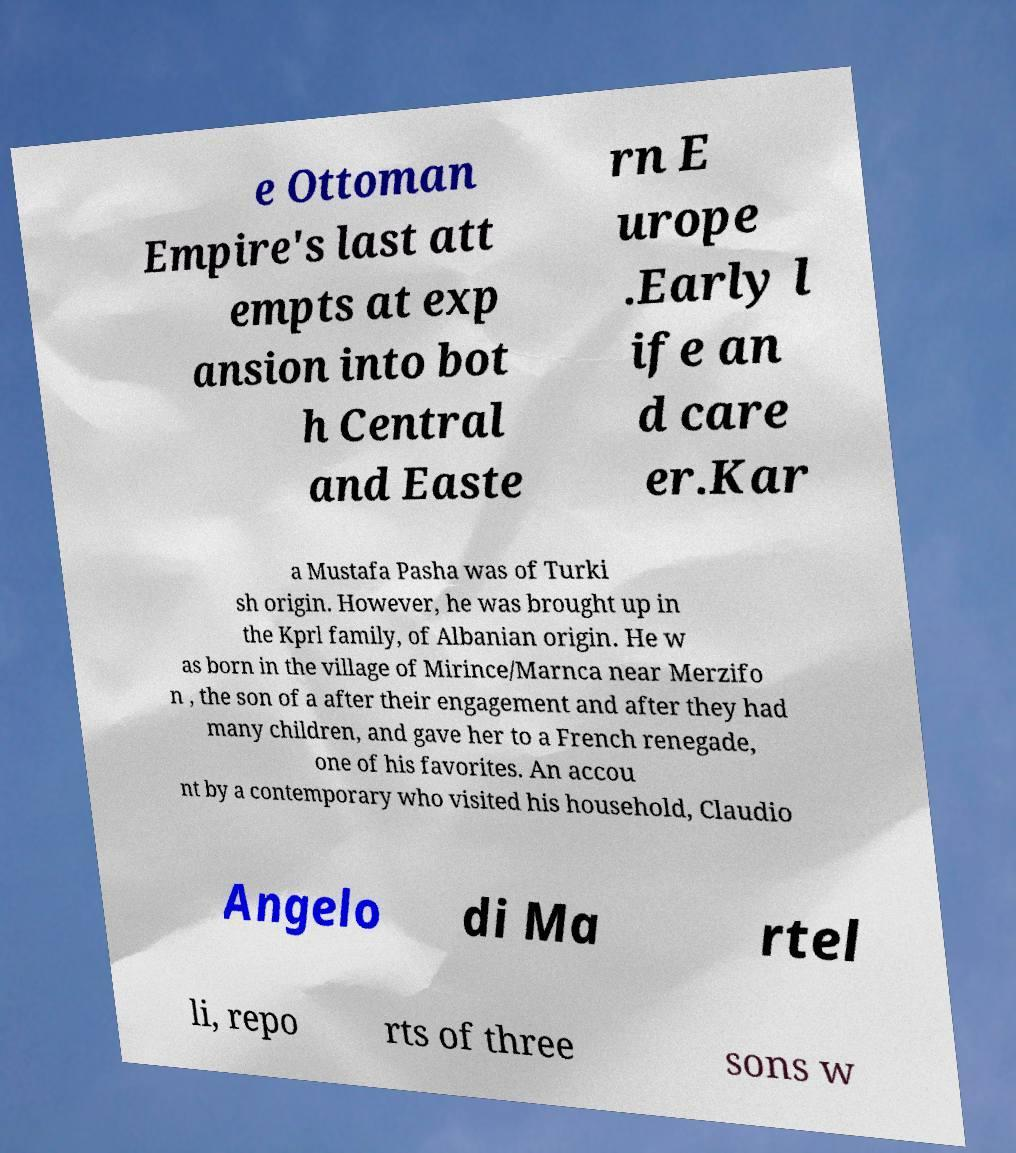What messages or text are displayed in this image? I need them in a readable, typed format. e Ottoman Empire's last att empts at exp ansion into bot h Central and Easte rn E urope .Early l ife an d care er.Kar a Mustafa Pasha was of Turki sh origin. However, he was brought up in the Kprl family, of Albanian origin. He w as born in the village of Mirince/Marnca near Merzifo n , the son of a after their engagement and after they had many children, and gave her to a French renegade, one of his favorites. An accou nt by a contemporary who visited his household, Claudio Angelo di Ma rtel li, repo rts of three sons w 